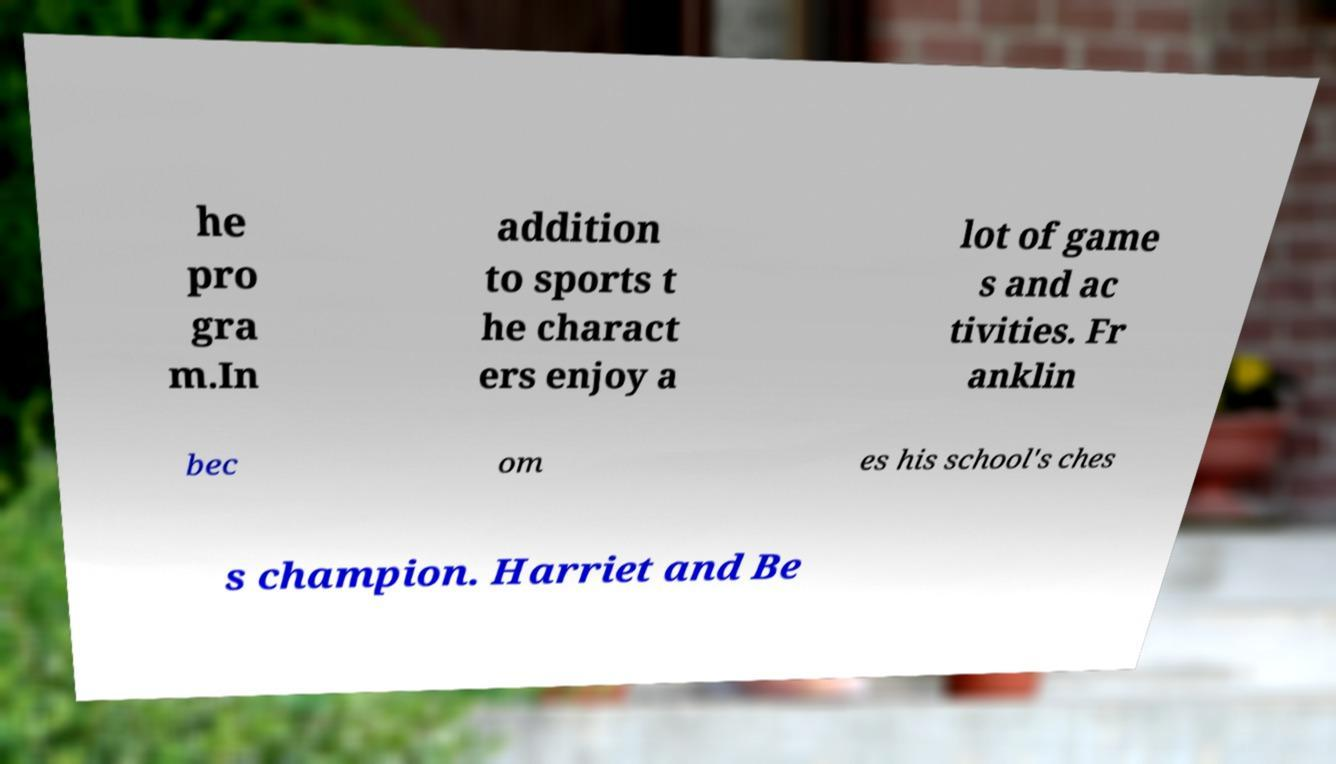Could you assist in decoding the text presented in this image and type it out clearly? he pro gra m.In addition to sports t he charact ers enjoy a lot of game s and ac tivities. Fr anklin bec om es his school's ches s champion. Harriet and Be 